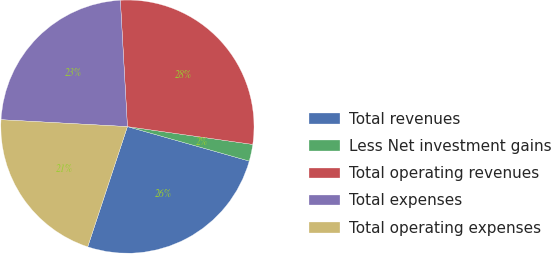Convert chart. <chart><loc_0><loc_0><loc_500><loc_500><pie_chart><fcel>Total revenues<fcel>Less Net investment gains<fcel>Total operating revenues<fcel>Total expenses<fcel>Total operating expenses<nl><fcel>25.69%<fcel>2.14%<fcel>28.14%<fcel>23.24%<fcel>20.79%<nl></chart> 